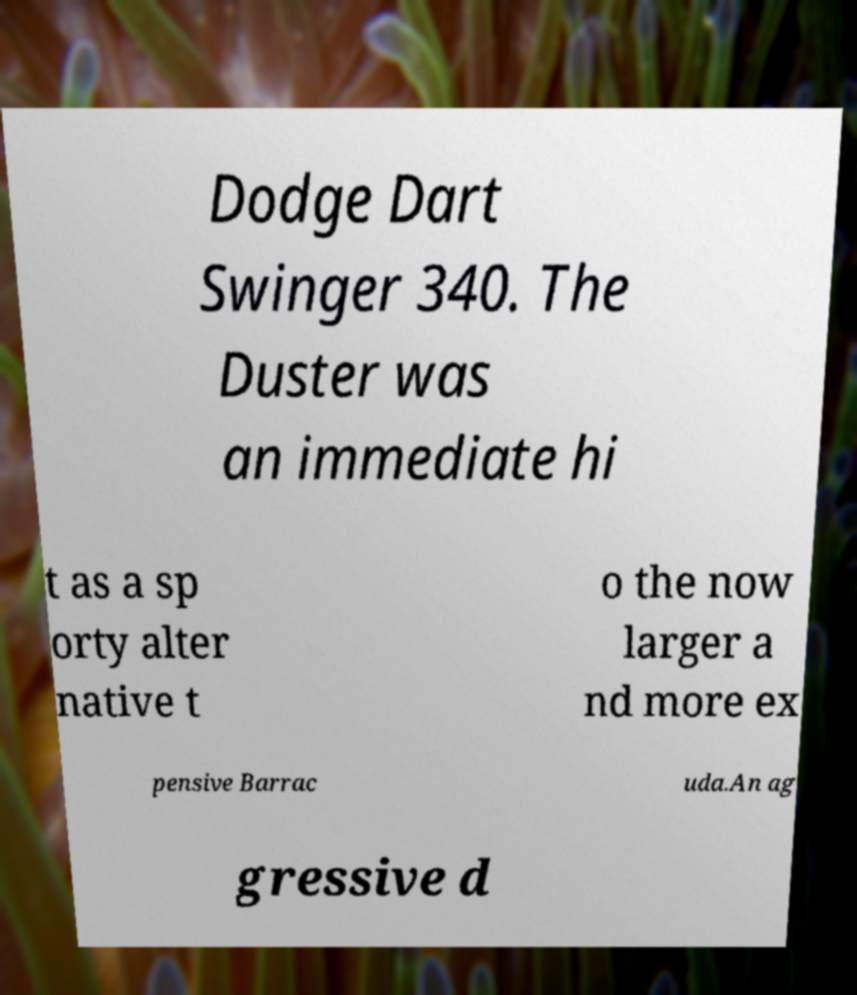Could you extract and type out the text from this image? Dodge Dart Swinger 340. The Duster was an immediate hi t as a sp orty alter native t o the now larger a nd more ex pensive Barrac uda.An ag gressive d 